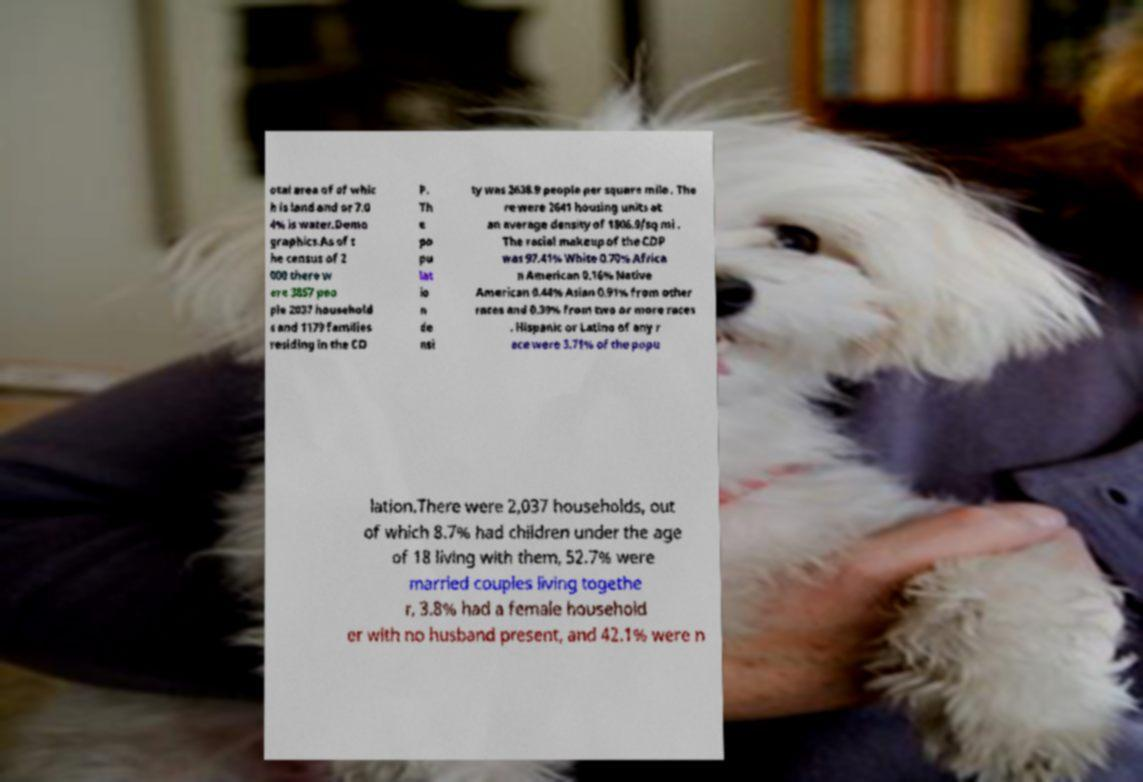Could you assist in decoding the text presented in this image and type it out clearly? otal area of of whic h is land and or 7.0 4% is water.Demo graphics.As of t he census of 2 000 there w ere 3857 peo ple 2037 household s and 1179 families residing in the CD P. Th e po pu lat io n de nsi ty was 2638.9 people per square mile . The re were 2641 housing units at an average density of 1806.9/sq mi . The racial makeup of the CDP was 97.41% White 0.70% Africa n American 0.16% Native American 0.44% Asian 0.91% from other races and 0.39% from two or more races . Hispanic or Latino of any r ace were 3.71% of the popu lation.There were 2,037 households, out of which 8.7% had children under the age of 18 living with them, 52.7% were married couples living togethe r, 3.8% had a female household er with no husband present, and 42.1% were n 